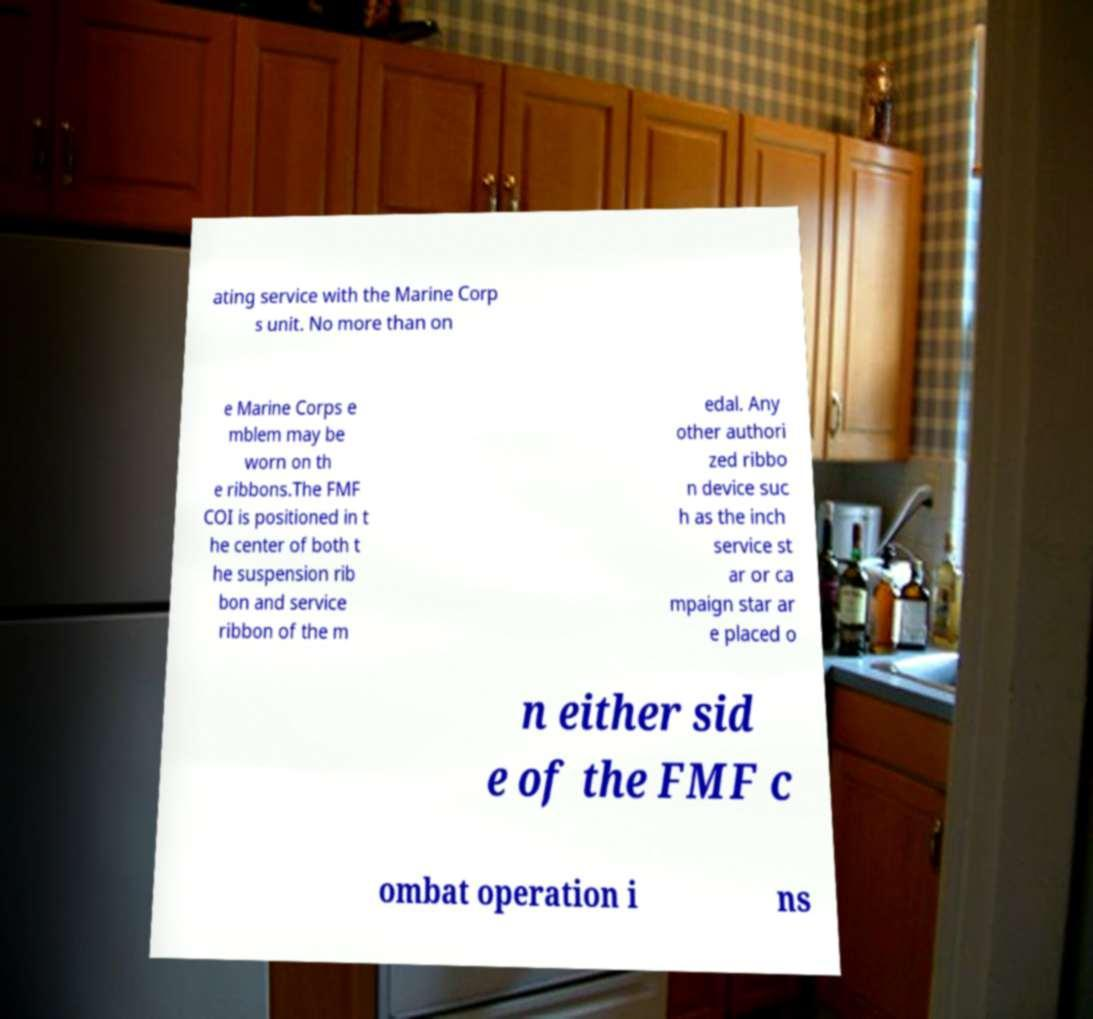Could you assist in decoding the text presented in this image and type it out clearly? ating service with the Marine Corp s unit. No more than on e Marine Corps e mblem may be worn on th e ribbons.The FMF COI is positioned in t he center of both t he suspension rib bon and service ribbon of the m edal. Any other authori zed ribbo n device suc h as the inch service st ar or ca mpaign star ar e placed o n either sid e of the FMF c ombat operation i ns 